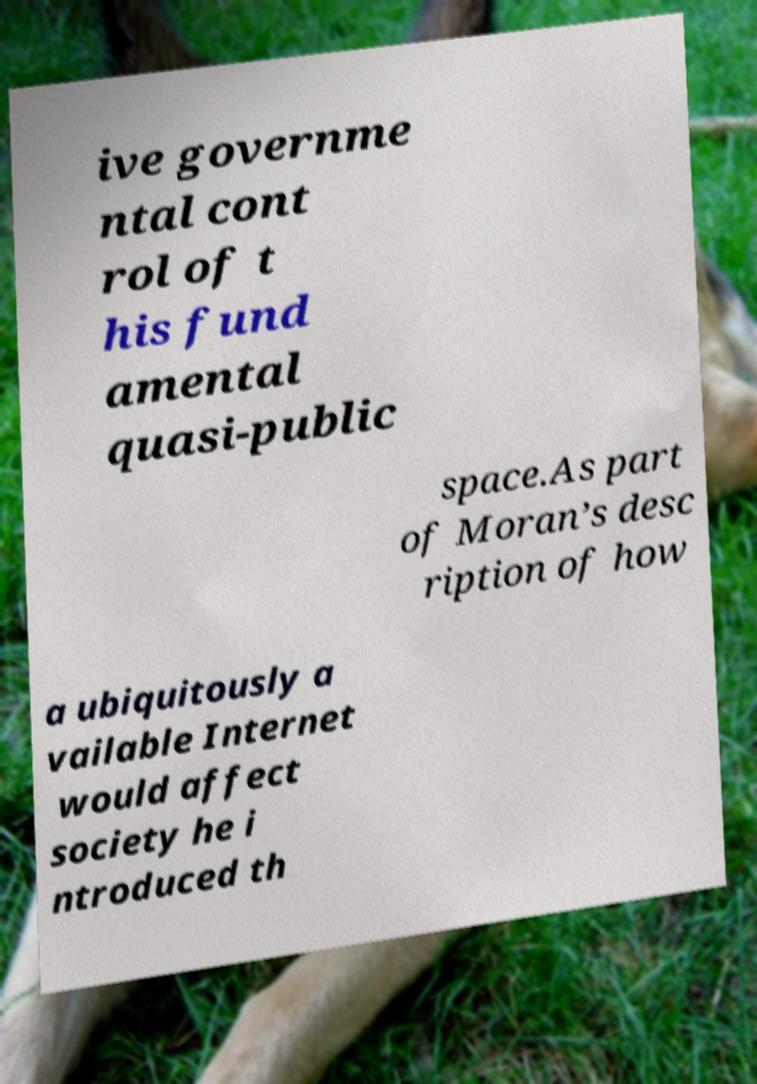I need the written content from this picture converted into text. Can you do that? ive governme ntal cont rol of t his fund amental quasi-public space.As part of Moran’s desc ription of how a ubiquitously a vailable Internet would affect society he i ntroduced th 